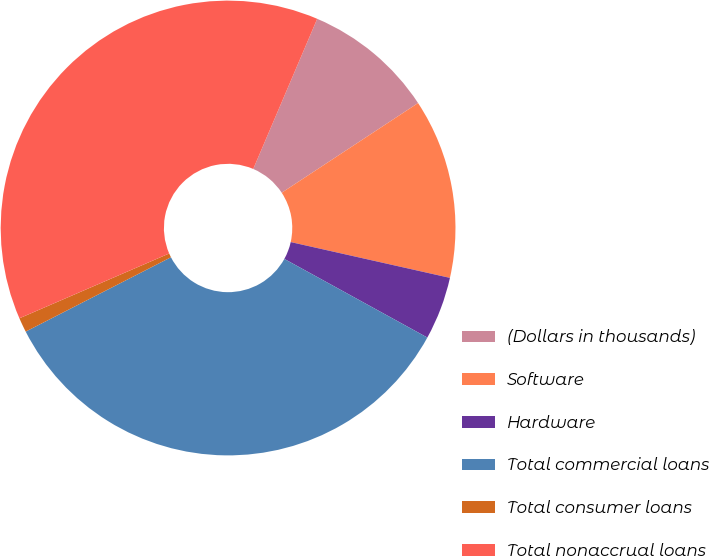Convert chart to OTSL. <chart><loc_0><loc_0><loc_500><loc_500><pie_chart><fcel>(Dollars in thousands)<fcel>Software<fcel>Hardware<fcel>Total commercial loans<fcel>Total consumer loans<fcel>Total nonaccrual loans<nl><fcel>9.33%<fcel>12.78%<fcel>4.48%<fcel>34.47%<fcel>1.03%<fcel>37.91%<nl></chart> 